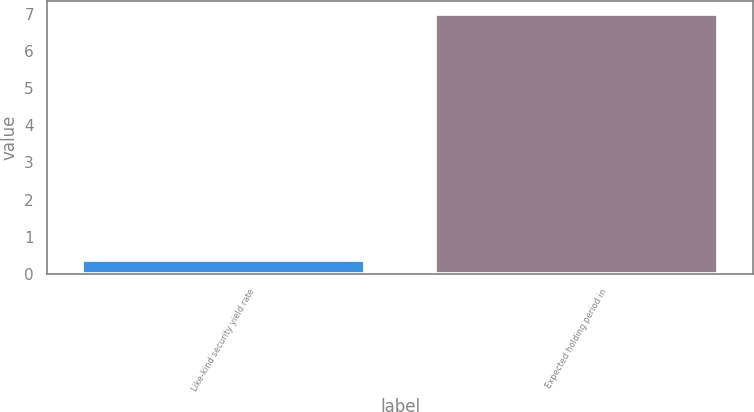Convert chart to OTSL. <chart><loc_0><loc_0><loc_500><loc_500><bar_chart><fcel>Like-kind security yield rate<fcel>Expected holding period in<nl><fcel>0.36<fcel>7<nl></chart> 